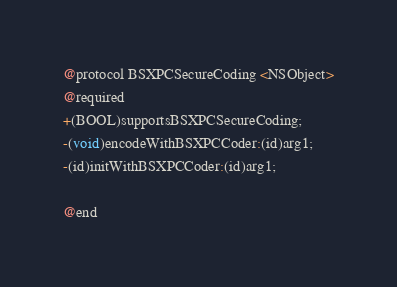Convert code to text. <code><loc_0><loc_0><loc_500><loc_500><_C_>

@protocol BSXPCSecureCoding <NSObject>
@required
+(BOOL)supportsBSXPCSecureCoding;
-(void)encodeWithBSXPCCoder:(id)arg1;
-(id)initWithBSXPCCoder:(id)arg1;

@end

</code> 